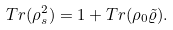<formula> <loc_0><loc_0><loc_500><loc_500>T r ( \rho _ { s } ^ { 2 } ) = 1 + T r ( \rho _ { 0 } \tilde { \varrho } ) .</formula> 